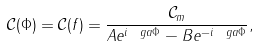Convert formula to latex. <formula><loc_0><loc_0><loc_500><loc_500>\mathcal { C } ( \Phi ) = \mathcal { C } ( f ) = \frac { \mathcal { C } _ { m } } { A e ^ { i \ g a \Phi } - B e ^ { - i \ g a \Phi } } ,</formula> 